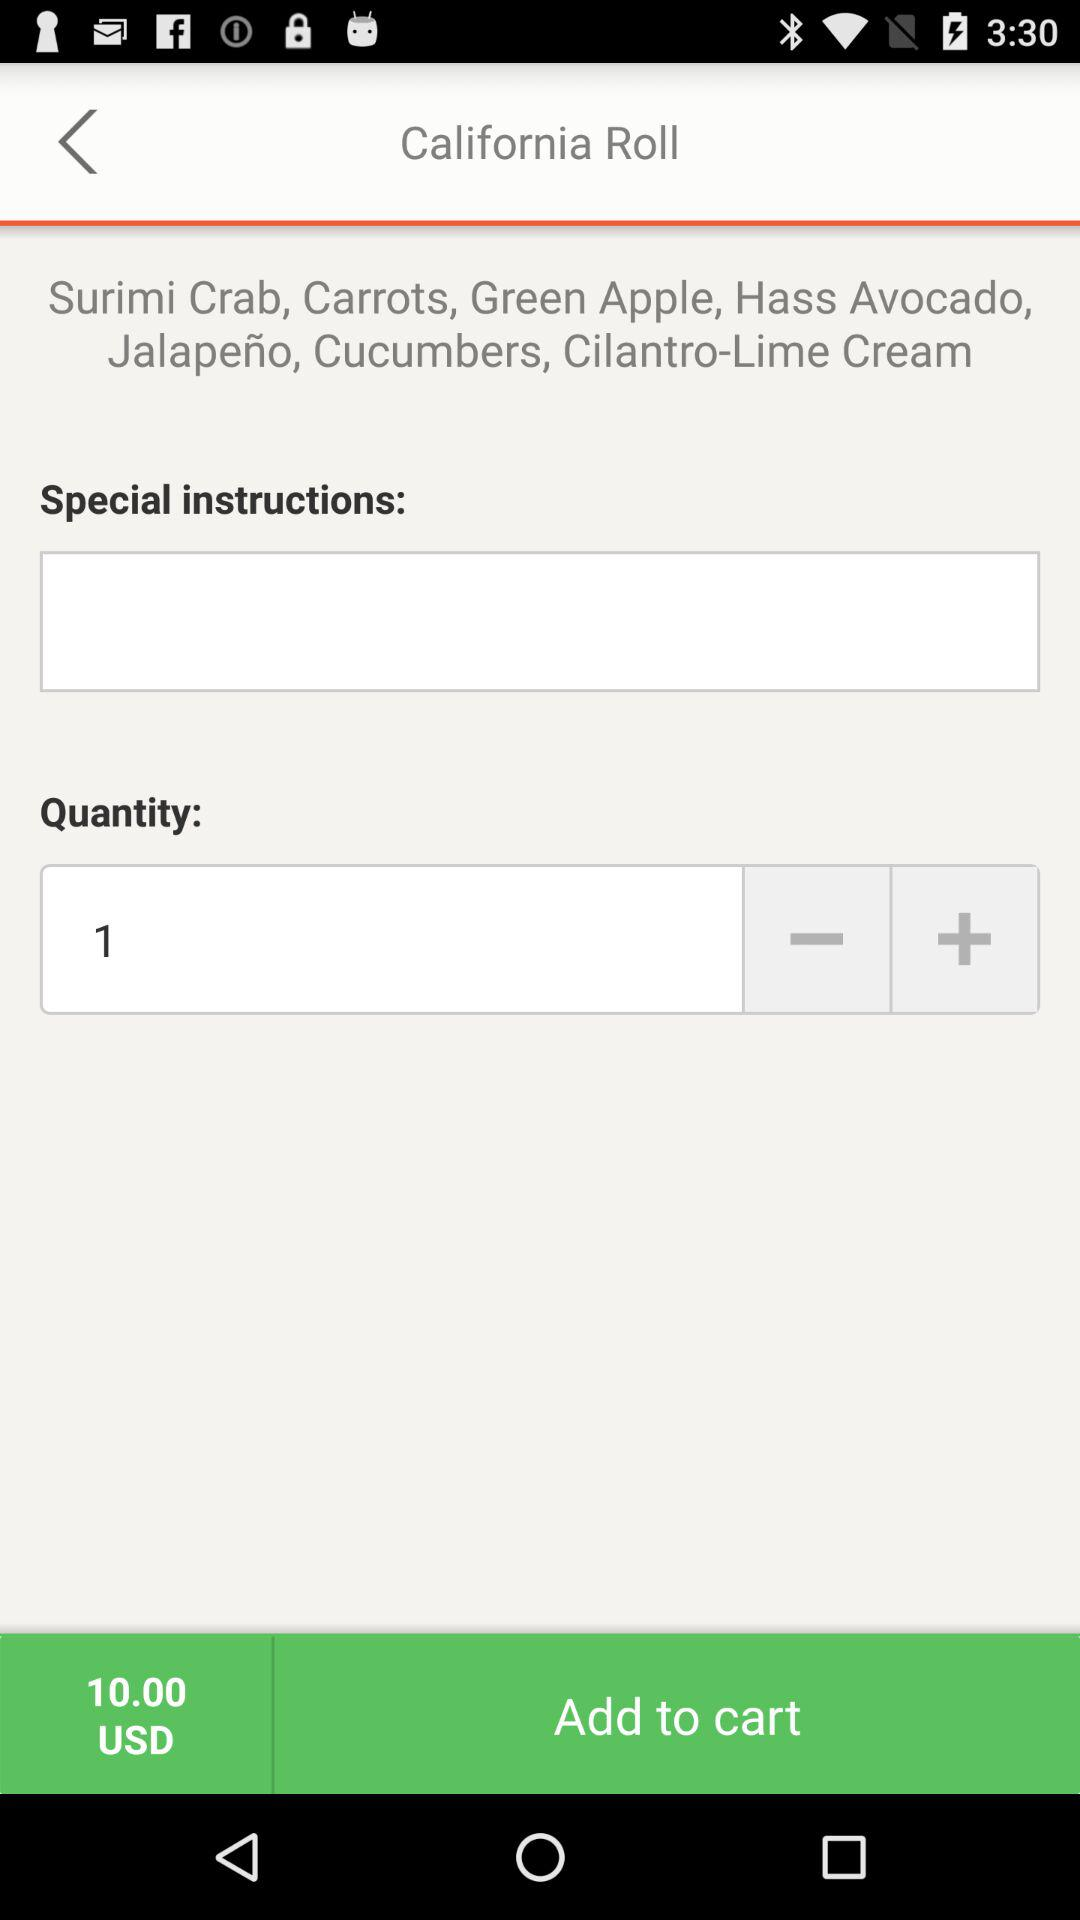What is the number of added quantities? The number of added quantities is 1. 